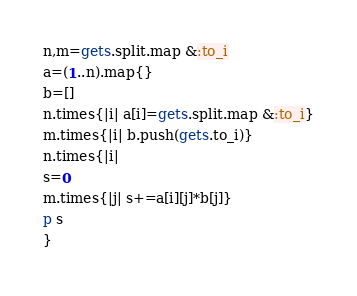<code> <loc_0><loc_0><loc_500><loc_500><_Ruby_>n,m=gets.split.map &:to_i
a=(1..n).map{}
b=[]
n.times{|i| a[i]=gets.split.map &:to_i}
m.times{|i| b.push(gets.to_i)}
n.times{|i|
s=0
m.times{|j| s+=a[i][j]*b[j]}
p s
}</code> 